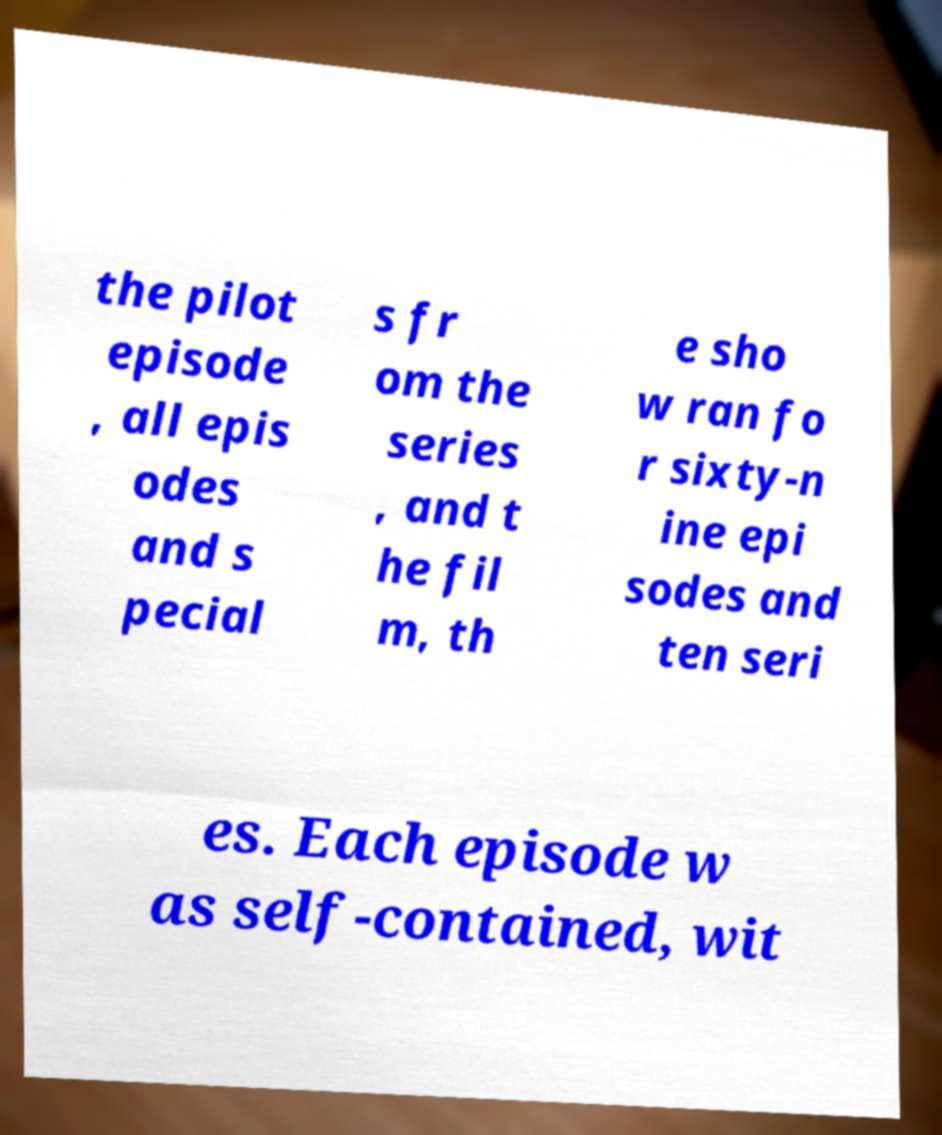Please identify and transcribe the text found in this image. the pilot episode , all epis odes and s pecial s fr om the series , and t he fil m, th e sho w ran fo r sixty-n ine epi sodes and ten seri es. Each episode w as self-contained, wit 